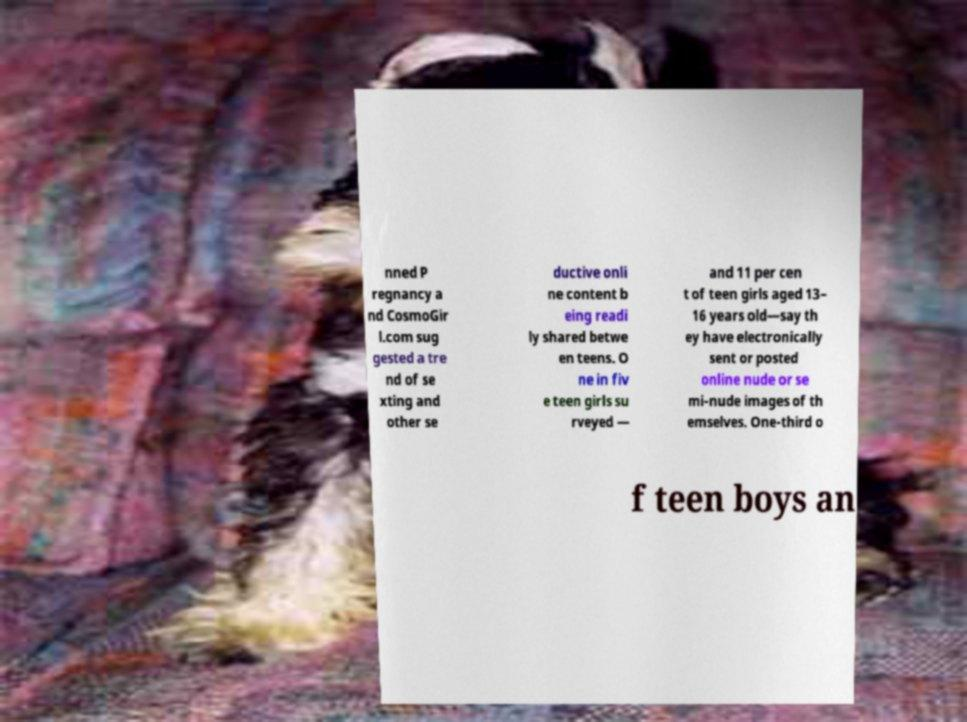I need the written content from this picture converted into text. Can you do that? nned P regnancy a nd CosmoGir l.com sug gested a tre nd of se xting and other se ductive onli ne content b eing readi ly shared betwe en teens. O ne in fiv e teen girls su rveyed — and 11 per cen t of teen girls aged 13– 16 years old—say th ey have electronically sent or posted online nude or se mi-nude images of th emselves. One-third o f teen boys an 